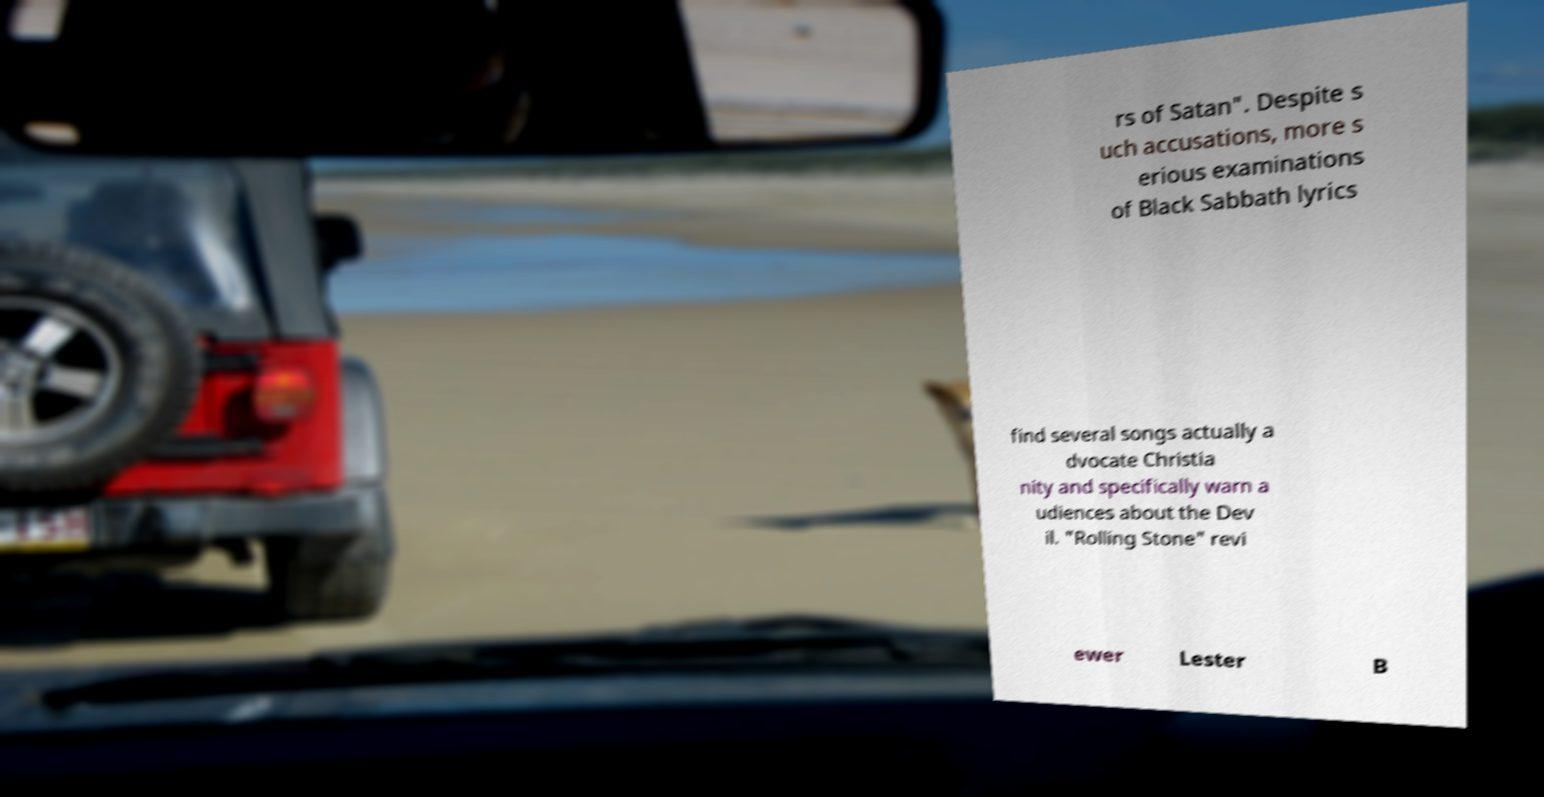For documentation purposes, I need the text within this image transcribed. Could you provide that? rs of Satan". Despite s uch accusations, more s erious examinations of Black Sabbath lyrics find several songs actually a dvocate Christia nity and specifically warn a udiences about the Dev il. "Rolling Stone" revi ewer Lester B 